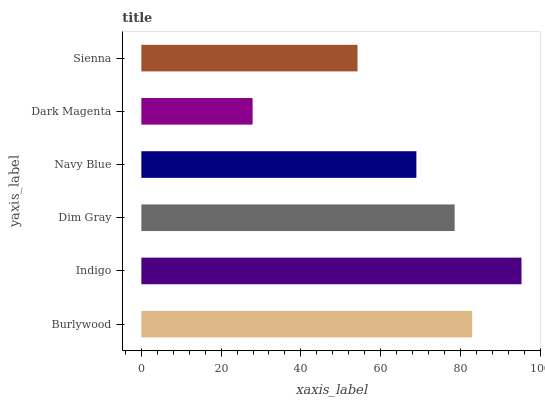Is Dark Magenta the minimum?
Answer yes or no. Yes. Is Indigo the maximum?
Answer yes or no. Yes. Is Dim Gray the minimum?
Answer yes or no. No. Is Dim Gray the maximum?
Answer yes or no. No. Is Indigo greater than Dim Gray?
Answer yes or no. Yes. Is Dim Gray less than Indigo?
Answer yes or no. Yes. Is Dim Gray greater than Indigo?
Answer yes or no. No. Is Indigo less than Dim Gray?
Answer yes or no. No. Is Dim Gray the high median?
Answer yes or no. Yes. Is Navy Blue the low median?
Answer yes or no. Yes. Is Dark Magenta the high median?
Answer yes or no. No. Is Sienna the low median?
Answer yes or no. No. 